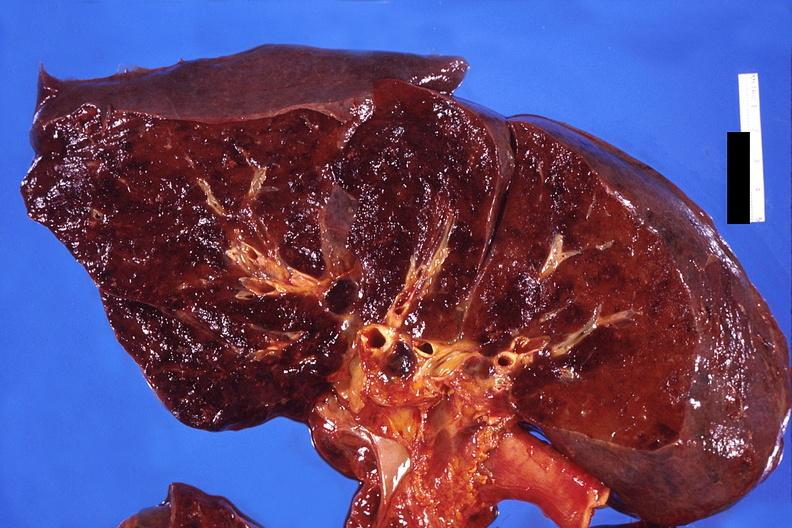s pituitary present?
Answer the question using a single word or phrase. No 